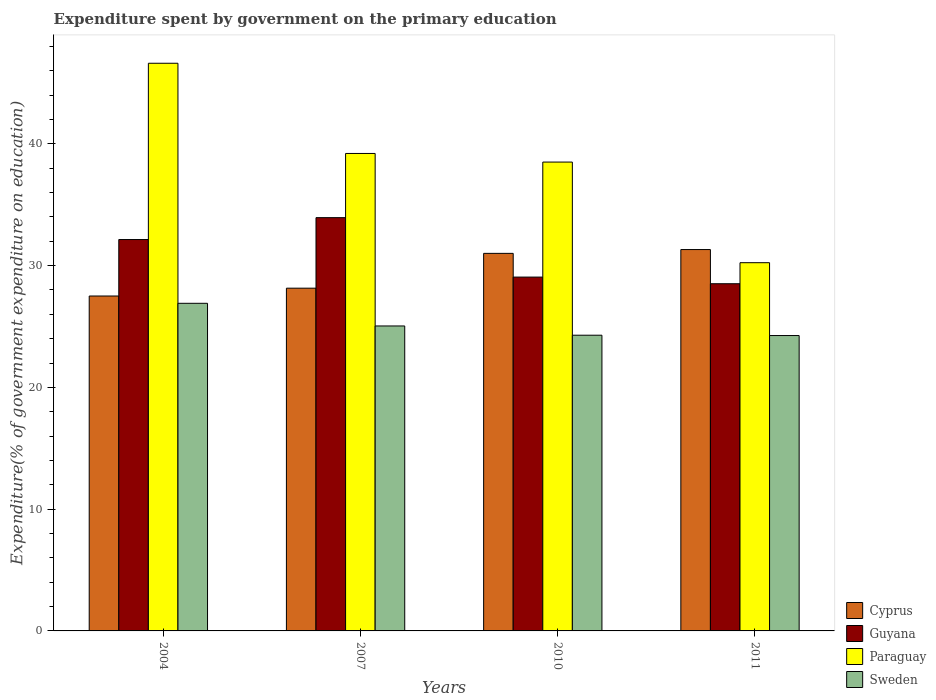How many different coloured bars are there?
Your answer should be compact. 4. How many groups of bars are there?
Give a very brief answer. 4. Are the number of bars on each tick of the X-axis equal?
Give a very brief answer. Yes. What is the label of the 3rd group of bars from the left?
Offer a very short reply. 2010. In how many cases, is the number of bars for a given year not equal to the number of legend labels?
Give a very brief answer. 0. What is the expenditure spent by government on the primary education in Sweden in 2010?
Ensure brevity in your answer.  24.29. Across all years, what is the maximum expenditure spent by government on the primary education in Guyana?
Offer a terse response. 33.94. Across all years, what is the minimum expenditure spent by government on the primary education in Sweden?
Your answer should be very brief. 24.26. In which year was the expenditure spent by government on the primary education in Paraguay maximum?
Ensure brevity in your answer.  2004. In which year was the expenditure spent by government on the primary education in Guyana minimum?
Offer a very short reply. 2011. What is the total expenditure spent by government on the primary education in Sweden in the graph?
Ensure brevity in your answer.  100.5. What is the difference between the expenditure spent by government on the primary education in Guyana in 2010 and that in 2011?
Your answer should be compact. 0.55. What is the difference between the expenditure spent by government on the primary education in Cyprus in 2011 and the expenditure spent by government on the primary education in Guyana in 2010?
Your answer should be very brief. 2.26. What is the average expenditure spent by government on the primary education in Guyana per year?
Offer a very short reply. 30.92. In the year 2011, what is the difference between the expenditure spent by government on the primary education in Guyana and expenditure spent by government on the primary education in Cyprus?
Keep it short and to the point. -2.81. In how many years, is the expenditure spent by government on the primary education in Cyprus greater than 12 %?
Make the answer very short. 4. What is the ratio of the expenditure spent by government on the primary education in Guyana in 2007 to that in 2011?
Your answer should be compact. 1.19. Is the difference between the expenditure spent by government on the primary education in Guyana in 2004 and 2010 greater than the difference between the expenditure spent by government on the primary education in Cyprus in 2004 and 2010?
Offer a very short reply. Yes. What is the difference between the highest and the second highest expenditure spent by government on the primary education in Sweden?
Offer a very short reply. 1.86. What is the difference between the highest and the lowest expenditure spent by government on the primary education in Sweden?
Keep it short and to the point. 2.65. In how many years, is the expenditure spent by government on the primary education in Guyana greater than the average expenditure spent by government on the primary education in Guyana taken over all years?
Offer a terse response. 2. What does the 2nd bar from the left in 2010 represents?
Provide a short and direct response. Guyana. What does the 2nd bar from the right in 2010 represents?
Provide a short and direct response. Paraguay. Is it the case that in every year, the sum of the expenditure spent by government on the primary education in Cyprus and expenditure spent by government on the primary education in Paraguay is greater than the expenditure spent by government on the primary education in Sweden?
Offer a terse response. Yes. How many bars are there?
Offer a terse response. 16. What is the difference between two consecutive major ticks on the Y-axis?
Your answer should be very brief. 10. How many legend labels are there?
Your answer should be compact. 4. What is the title of the graph?
Make the answer very short. Expenditure spent by government on the primary education. Does "Curacao" appear as one of the legend labels in the graph?
Ensure brevity in your answer.  No. What is the label or title of the Y-axis?
Provide a succinct answer. Expenditure(% of government expenditure on education). What is the Expenditure(% of government expenditure on education) of Cyprus in 2004?
Ensure brevity in your answer.  27.51. What is the Expenditure(% of government expenditure on education) of Guyana in 2004?
Offer a terse response. 32.14. What is the Expenditure(% of government expenditure on education) of Paraguay in 2004?
Ensure brevity in your answer.  46.62. What is the Expenditure(% of government expenditure on education) of Sweden in 2004?
Provide a succinct answer. 26.91. What is the Expenditure(% of government expenditure on education) of Cyprus in 2007?
Provide a succinct answer. 28.15. What is the Expenditure(% of government expenditure on education) in Guyana in 2007?
Your answer should be compact. 33.94. What is the Expenditure(% of government expenditure on education) in Paraguay in 2007?
Provide a short and direct response. 39.21. What is the Expenditure(% of government expenditure on education) in Sweden in 2007?
Offer a terse response. 25.05. What is the Expenditure(% of government expenditure on education) in Cyprus in 2010?
Ensure brevity in your answer.  31.01. What is the Expenditure(% of government expenditure on education) of Guyana in 2010?
Ensure brevity in your answer.  29.06. What is the Expenditure(% of government expenditure on education) of Paraguay in 2010?
Keep it short and to the point. 38.51. What is the Expenditure(% of government expenditure on education) in Sweden in 2010?
Provide a short and direct response. 24.29. What is the Expenditure(% of government expenditure on education) of Cyprus in 2011?
Provide a short and direct response. 31.32. What is the Expenditure(% of government expenditure on education) of Guyana in 2011?
Provide a succinct answer. 28.51. What is the Expenditure(% of government expenditure on education) in Paraguay in 2011?
Your response must be concise. 30.24. What is the Expenditure(% of government expenditure on education) in Sweden in 2011?
Give a very brief answer. 24.26. Across all years, what is the maximum Expenditure(% of government expenditure on education) of Cyprus?
Keep it short and to the point. 31.32. Across all years, what is the maximum Expenditure(% of government expenditure on education) of Guyana?
Make the answer very short. 33.94. Across all years, what is the maximum Expenditure(% of government expenditure on education) in Paraguay?
Your response must be concise. 46.62. Across all years, what is the maximum Expenditure(% of government expenditure on education) of Sweden?
Your answer should be very brief. 26.91. Across all years, what is the minimum Expenditure(% of government expenditure on education) in Cyprus?
Offer a very short reply. 27.51. Across all years, what is the minimum Expenditure(% of government expenditure on education) in Guyana?
Your answer should be compact. 28.51. Across all years, what is the minimum Expenditure(% of government expenditure on education) of Paraguay?
Offer a very short reply. 30.24. Across all years, what is the minimum Expenditure(% of government expenditure on education) of Sweden?
Your response must be concise. 24.26. What is the total Expenditure(% of government expenditure on education) in Cyprus in the graph?
Make the answer very short. 117.99. What is the total Expenditure(% of government expenditure on education) in Guyana in the graph?
Your answer should be very brief. 123.66. What is the total Expenditure(% of government expenditure on education) in Paraguay in the graph?
Your answer should be compact. 154.58. What is the total Expenditure(% of government expenditure on education) of Sweden in the graph?
Give a very brief answer. 100.5. What is the difference between the Expenditure(% of government expenditure on education) of Cyprus in 2004 and that in 2007?
Ensure brevity in your answer.  -0.64. What is the difference between the Expenditure(% of government expenditure on education) of Guyana in 2004 and that in 2007?
Your answer should be very brief. -1.8. What is the difference between the Expenditure(% of government expenditure on education) of Paraguay in 2004 and that in 2007?
Your answer should be compact. 7.41. What is the difference between the Expenditure(% of government expenditure on education) in Sweden in 2004 and that in 2007?
Your response must be concise. 1.86. What is the difference between the Expenditure(% of government expenditure on education) in Cyprus in 2004 and that in 2010?
Your answer should be very brief. -3.5. What is the difference between the Expenditure(% of government expenditure on education) in Guyana in 2004 and that in 2010?
Provide a short and direct response. 3.08. What is the difference between the Expenditure(% of government expenditure on education) of Paraguay in 2004 and that in 2010?
Give a very brief answer. 8.12. What is the difference between the Expenditure(% of government expenditure on education) of Sweden in 2004 and that in 2010?
Provide a short and direct response. 2.62. What is the difference between the Expenditure(% of government expenditure on education) of Cyprus in 2004 and that in 2011?
Make the answer very short. -3.82. What is the difference between the Expenditure(% of government expenditure on education) in Guyana in 2004 and that in 2011?
Your answer should be very brief. 3.63. What is the difference between the Expenditure(% of government expenditure on education) of Paraguay in 2004 and that in 2011?
Your answer should be compact. 16.38. What is the difference between the Expenditure(% of government expenditure on education) of Sweden in 2004 and that in 2011?
Provide a succinct answer. 2.65. What is the difference between the Expenditure(% of government expenditure on education) of Cyprus in 2007 and that in 2010?
Your answer should be very brief. -2.86. What is the difference between the Expenditure(% of government expenditure on education) of Guyana in 2007 and that in 2010?
Provide a succinct answer. 4.88. What is the difference between the Expenditure(% of government expenditure on education) in Paraguay in 2007 and that in 2010?
Your response must be concise. 0.71. What is the difference between the Expenditure(% of government expenditure on education) of Sweden in 2007 and that in 2010?
Your answer should be compact. 0.76. What is the difference between the Expenditure(% of government expenditure on education) of Cyprus in 2007 and that in 2011?
Your answer should be very brief. -3.17. What is the difference between the Expenditure(% of government expenditure on education) in Guyana in 2007 and that in 2011?
Your answer should be compact. 5.43. What is the difference between the Expenditure(% of government expenditure on education) in Paraguay in 2007 and that in 2011?
Your response must be concise. 8.97. What is the difference between the Expenditure(% of government expenditure on education) in Sweden in 2007 and that in 2011?
Give a very brief answer. 0.79. What is the difference between the Expenditure(% of government expenditure on education) in Cyprus in 2010 and that in 2011?
Ensure brevity in your answer.  -0.31. What is the difference between the Expenditure(% of government expenditure on education) of Guyana in 2010 and that in 2011?
Your response must be concise. 0.55. What is the difference between the Expenditure(% of government expenditure on education) of Paraguay in 2010 and that in 2011?
Keep it short and to the point. 8.26. What is the difference between the Expenditure(% of government expenditure on education) of Sweden in 2010 and that in 2011?
Keep it short and to the point. 0.03. What is the difference between the Expenditure(% of government expenditure on education) of Cyprus in 2004 and the Expenditure(% of government expenditure on education) of Guyana in 2007?
Offer a terse response. -6.44. What is the difference between the Expenditure(% of government expenditure on education) of Cyprus in 2004 and the Expenditure(% of government expenditure on education) of Paraguay in 2007?
Your response must be concise. -11.71. What is the difference between the Expenditure(% of government expenditure on education) of Cyprus in 2004 and the Expenditure(% of government expenditure on education) of Sweden in 2007?
Offer a very short reply. 2.46. What is the difference between the Expenditure(% of government expenditure on education) in Guyana in 2004 and the Expenditure(% of government expenditure on education) in Paraguay in 2007?
Your answer should be very brief. -7.07. What is the difference between the Expenditure(% of government expenditure on education) in Guyana in 2004 and the Expenditure(% of government expenditure on education) in Sweden in 2007?
Offer a very short reply. 7.1. What is the difference between the Expenditure(% of government expenditure on education) of Paraguay in 2004 and the Expenditure(% of government expenditure on education) of Sweden in 2007?
Keep it short and to the point. 21.58. What is the difference between the Expenditure(% of government expenditure on education) of Cyprus in 2004 and the Expenditure(% of government expenditure on education) of Guyana in 2010?
Make the answer very short. -1.55. What is the difference between the Expenditure(% of government expenditure on education) in Cyprus in 2004 and the Expenditure(% of government expenditure on education) in Paraguay in 2010?
Keep it short and to the point. -11. What is the difference between the Expenditure(% of government expenditure on education) of Cyprus in 2004 and the Expenditure(% of government expenditure on education) of Sweden in 2010?
Keep it short and to the point. 3.22. What is the difference between the Expenditure(% of government expenditure on education) of Guyana in 2004 and the Expenditure(% of government expenditure on education) of Paraguay in 2010?
Offer a very short reply. -6.36. What is the difference between the Expenditure(% of government expenditure on education) in Guyana in 2004 and the Expenditure(% of government expenditure on education) in Sweden in 2010?
Provide a short and direct response. 7.86. What is the difference between the Expenditure(% of government expenditure on education) of Paraguay in 2004 and the Expenditure(% of government expenditure on education) of Sweden in 2010?
Make the answer very short. 22.34. What is the difference between the Expenditure(% of government expenditure on education) in Cyprus in 2004 and the Expenditure(% of government expenditure on education) in Guyana in 2011?
Your answer should be very brief. -1.01. What is the difference between the Expenditure(% of government expenditure on education) in Cyprus in 2004 and the Expenditure(% of government expenditure on education) in Paraguay in 2011?
Your response must be concise. -2.74. What is the difference between the Expenditure(% of government expenditure on education) of Cyprus in 2004 and the Expenditure(% of government expenditure on education) of Sweden in 2011?
Give a very brief answer. 3.25. What is the difference between the Expenditure(% of government expenditure on education) of Guyana in 2004 and the Expenditure(% of government expenditure on education) of Paraguay in 2011?
Offer a very short reply. 1.9. What is the difference between the Expenditure(% of government expenditure on education) in Guyana in 2004 and the Expenditure(% of government expenditure on education) in Sweden in 2011?
Your answer should be compact. 7.88. What is the difference between the Expenditure(% of government expenditure on education) in Paraguay in 2004 and the Expenditure(% of government expenditure on education) in Sweden in 2011?
Your answer should be very brief. 22.36. What is the difference between the Expenditure(% of government expenditure on education) in Cyprus in 2007 and the Expenditure(% of government expenditure on education) in Guyana in 2010?
Offer a very short reply. -0.91. What is the difference between the Expenditure(% of government expenditure on education) of Cyprus in 2007 and the Expenditure(% of government expenditure on education) of Paraguay in 2010?
Give a very brief answer. -10.36. What is the difference between the Expenditure(% of government expenditure on education) of Cyprus in 2007 and the Expenditure(% of government expenditure on education) of Sweden in 2010?
Offer a terse response. 3.86. What is the difference between the Expenditure(% of government expenditure on education) in Guyana in 2007 and the Expenditure(% of government expenditure on education) in Paraguay in 2010?
Ensure brevity in your answer.  -4.56. What is the difference between the Expenditure(% of government expenditure on education) of Guyana in 2007 and the Expenditure(% of government expenditure on education) of Sweden in 2010?
Ensure brevity in your answer.  9.66. What is the difference between the Expenditure(% of government expenditure on education) in Paraguay in 2007 and the Expenditure(% of government expenditure on education) in Sweden in 2010?
Provide a short and direct response. 14.93. What is the difference between the Expenditure(% of government expenditure on education) of Cyprus in 2007 and the Expenditure(% of government expenditure on education) of Guyana in 2011?
Give a very brief answer. -0.37. What is the difference between the Expenditure(% of government expenditure on education) of Cyprus in 2007 and the Expenditure(% of government expenditure on education) of Paraguay in 2011?
Your response must be concise. -2.09. What is the difference between the Expenditure(% of government expenditure on education) of Cyprus in 2007 and the Expenditure(% of government expenditure on education) of Sweden in 2011?
Your response must be concise. 3.89. What is the difference between the Expenditure(% of government expenditure on education) of Guyana in 2007 and the Expenditure(% of government expenditure on education) of Paraguay in 2011?
Provide a succinct answer. 3.7. What is the difference between the Expenditure(% of government expenditure on education) of Guyana in 2007 and the Expenditure(% of government expenditure on education) of Sweden in 2011?
Your response must be concise. 9.68. What is the difference between the Expenditure(% of government expenditure on education) of Paraguay in 2007 and the Expenditure(% of government expenditure on education) of Sweden in 2011?
Provide a short and direct response. 14.95. What is the difference between the Expenditure(% of government expenditure on education) in Cyprus in 2010 and the Expenditure(% of government expenditure on education) in Guyana in 2011?
Your response must be concise. 2.49. What is the difference between the Expenditure(% of government expenditure on education) in Cyprus in 2010 and the Expenditure(% of government expenditure on education) in Paraguay in 2011?
Make the answer very short. 0.77. What is the difference between the Expenditure(% of government expenditure on education) in Cyprus in 2010 and the Expenditure(% of government expenditure on education) in Sweden in 2011?
Offer a terse response. 6.75. What is the difference between the Expenditure(% of government expenditure on education) in Guyana in 2010 and the Expenditure(% of government expenditure on education) in Paraguay in 2011?
Provide a short and direct response. -1.18. What is the difference between the Expenditure(% of government expenditure on education) in Guyana in 2010 and the Expenditure(% of government expenditure on education) in Sweden in 2011?
Your answer should be compact. 4.8. What is the difference between the Expenditure(% of government expenditure on education) in Paraguay in 2010 and the Expenditure(% of government expenditure on education) in Sweden in 2011?
Make the answer very short. 14.25. What is the average Expenditure(% of government expenditure on education) of Cyprus per year?
Your response must be concise. 29.5. What is the average Expenditure(% of government expenditure on education) in Guyana per year?
Provide a short and direct response. 30.91. What is the average Expenditure(% of government expenditure on education) of Paraguay per year?
Your answer should be compact. 38.65. What is the average Expenditure(% of government expenditure on education) of Sweden per year?
Provide a succinct answer. 25.12. In the year 2004, what is the difference between the Expenditure(% of government expenditure on education) in Cyprus and Expenditure(% of government expenditure on education) in Guyana?
Make the answer very short. -4.64. In the year 2004, what is the difference between the Expenditure(% of government expenditure on education) in Cyprus and Expenditure(% of government expenditure on education) in Paraguay?
Provide a succinct answer. -19.12. In the year 2004, what is the difference between the Expenditure(% of government expenditure on education) in Cyprus and Expenditure(% of government expenditure on education) in Sweden?
Provide a short and direct response. 0.6. In the year 2004, what is the difference between the Expenditure(% of government expenditure on education) in Guyana and Expenditure(% of government expenditure on education) in Paraguay?
Offer a terse response. -14.48. In the year 2004, what is the difference between the Expenditure(% of government expenditure on education) of Guyana and Expenditure(% of government expenditure on education) of Sweden?
Give a very brief answer. 5.24. In the year 2004, what is the difference between the Expenditure(% of government expenditure on education) of Paraguay and Expenditure(% of government expenditure on education) of Sweden?
Provide a succinct answer. 19.72. In the year 2007, what is the difference between the Expenditure(% of government expenditure on education) in Cyprus and Expenditure(% of government expenditure on education) in Guyana?
Make the answer very short. -5.79. In the year 2007, what is the difference between the Expenditure(% of government expenditure on education) in Cyprus and Expenditure(% of government expenditure on education) in Paraguay?
Provide a short and direct response. -11.06. In the year 2007, what is the difference between the Expenditure(% of government expenditure on education) of Cyprus and Expenditure(% of government expenditure on education) of Sweden?
Offer a terse response. 3.1. In the year 2007, what is the difference between the Expenditure(% of government expenditure on education) of Guyana and Expenditure(% of government expenditure on education) of Paraguay?
Keep it short and to the point. -5.27. In the year 2007, what is the difference between the Expenditure(% of government expenditure on education) in Guyana and Expenditure(% of government expenditure on education) in Sweden?
Your response must be concise. 8.9. In the year 2007, what is the difference between the Expenditure(% of government expenditure on education) of Paraguay and Expenditure(% of government expenditure on education) of Sweden?
Keep it short and to the point. 14.17. In the year 2010, what is the difference between the Expenditure(% of government expenditure on education) in Cyprus and Expenditure(% of government expenditure on education) in Guyana?
Your answer should be compact. 1.95. In the year 2010, what is the difference between the Expenditure(% of government expenditure on education) in Cyprus and Expenditure(% of government expenditure on education) in Paraguay?
Your answer should be compact. -7.5. In the year 2010, what is the difference between the Expenditure(% of government expenditure on education) of Cyprus and Expenditure(% of government expenditure on education) of Sweden?
Ensure brevity in your answer.  6.72. In the year 2010, what is the difference between the Expenditure(% of government expenditure on education) in Guyana and Expenditure(% of government expenditure on education) in Paraguay?
Provide a short and direct response. -9.45. In the year 2010, what is the difference between the Expenditure(% of government expenditure on education) of Guyana and Expenditure(% of government expenditure on education) of Sweden?
Provide a short and direct response. 4.77. In the year 2010, what is the difference between the Expenditure(% of government expenditure on education) in Paraguay and Expenditure(% of government expenditure on education) in Sweden?
Your answer should be very brief. 14.22. In the year 2011, what is the difference between the Expenditure(% of government expenditure on education) in Cyprus and Expenditure(% of government expenditure on education) in Guyana?
Give a very brief answer. 2.81. In the year 2011, what is the difference between the Expenditure(% of government expenditure on education) of Cyprus and Expenditure(% of government expenditure on education) of Paraguay?
Your answer should be compact. 1.08. In the year 2011, what is the difference between the Expenditure(% of government expenditure on education) of Cyprus and Expenditure(% of government expenditure on education) of Sweden?
Your response must be concise. 7.06. In the year 2011, what is the difference between the Expenditure(% of government expenditure on education) in Guyana and Expenditure(% of government expenditure on education) in Paraguay?
Your response must be concise. -1.73. In the year 2011, what is the difference between the Expenditure(% of government expenditure on education) in Guyana and Expenditure(% of government expenditure on education) in Sweden?
Your response must be concise. 4.25. In the year 2011, what is the difference between the Expenditure(% of government expenditure on education) in Paraguay and Expenditure(% of government expenditure on education) in Sweden?
Give a very brief answer. 5.98. What is the ratio of the Expenditure(% of government expenditure on education) in Cyprus in 2004 to that in 2007?
Provide a succinct answer. 0.98. What is the ratio of the Expenditure(% of government expenditure on education) of Guyana in 2004 to that in 2007?
Your answer should be compact. 0.95. What is the ratio of the Expenditure(% of government expenditure on education) in Paraguay in 2004 to that in 2007?
Offer a terse response. 1.19. What is the ratio of the Expenditure(% of government expenditure on education) in Sweden in 2004 to that in 2007?
Make the answer very short. 1.07. What is the ratio of the Expenditure(% of government expenditure on education) of Cyprus in 2004 to that in 2010?
Ensure brevity in your answer.  0.89. What is the ratio of the Expenditure(% of government expenditure on education) of Guyana in 2004 to that in 2010?
Offer a terse response. 1.11. What is the ratio of the Expenditure(% of government expenditure on education) of Paraguay in 2004 to that in 2010?
Make the answer very short. 1.21. What is the ratio of the Expenditure(% of government expenditure on education) of Sweden in 2004 to that in 2010?
Provide a short and direct response. 1.11. What is the ratio of the Expenditure(% of government expenditure on education) of Cyprus in 2004 to that in 2011?
Keep it short and to the point. 0.88. What is the ratio of the Expenditure(% of government expenditure on education) in Guyana in 2004 to that in 2011?
Provide a short and direct response. 1.13. What is the ratio of the Expenditure(% of government expenditure on education) in Paraguay in 2004 to that in 2011?
Offer a very short reply. 1.54. What is the ratio of the Expenditure(% of government expenditure on education) in Sweden in 2004 to that in 2011?
Your response must be concise. 1.11. What is the ratio of the Expenditure(% of government expenditure on education) in Cyprus in 2007 to that in 2010?
Offer a very short reply. 0.91. What is the ratio of the Expenditure(% of government expenditure on education) in Guyana in 2007 to that in 2010?
Offer a very short reply. 1.17. What is the ratio of the Expenditure(% of government expenditure on education) in Paraguay in 2007 to that in 2010?
Your answer should be compact. 1.02. What is the ratio of the Expenditure(% of government expenditure on education) of Sweden in 2007 to that in 2010?
Provide a succinct answer. 1.03. What is the ratio of the Expenditure(% of government expenditure on education) of Cyprus in 2007 to that in 2011?
Offer a very short reply. 0.9. What is the ratio of the Expenditure(% of government expenditure on education) in Guyana in 2007 to that in 2011?
Your answer should be compact. 1.19. What is the ratio of the Expenditure(% of government expenditure on education) in Paraguay in 2007 to that in 2011?
Provide a succinct answer. 1.3. What is the ratio of the Expenditure(% of government expenditure on education) of Sweden in 2007 to that in 2011?
Your response must be concise. 1.03. What is the ratio of the Expenditure(% of government expenditure on education) of Cyprus in 2010 to that in 2011?
Make the answer very short. 0.99. What is the ratio of the Expenditure(% of government expenditure on education) of Guyana in 2010 to that in 2011?
Provide a succinct answer. 1.02. What is the ratio of the Expenditure(% of government expenditure on education) of Paraguay in 2010 to that in 2011?
Your answer should be compact. 1.27. What is the ratio of the Expenditure(% of government expenditure on education) in Sweden in 2010 to that in 2011?
Offer a terse response. 1. What is the difference between the highest and the second highest Expenditure(% of government expenditure on education) of Cyprus?
Make the answer very short. 0.31. What is the difference between the highest and the second highest Expenditure(% of government expenditure on education) in Guyana?
Keep it short and to the point. 1.8. What is the difference between the highest and the second highest Expenditure(% of government expenditure on education) in Paraguay?
Offer a very short reply. 7.41. What is the difference between the highest and the second highest Expenditure(% of government expenditure on education) of Sweden?
Your response must be concise. 1.86. What is the difference between the highest and the lowest Expenditure(% of government expenditure on education) in Cyprus?
Your answer should be compact. 3.82. What is the difference between the highest and the lowest Expenditure(% of government expenditure on education) of Guyana?
Your answer should be very brief. 5.43. What is the difference between the highest and the lowest Expenditure(% of government expenditure on education) of Paraguay?
Provide a short and direct response. 16.38. What is the difference between the highest and the lowest Expenditure(% of government expenditure on education) of Sweden?
Give a very brief answer. 2.65. 